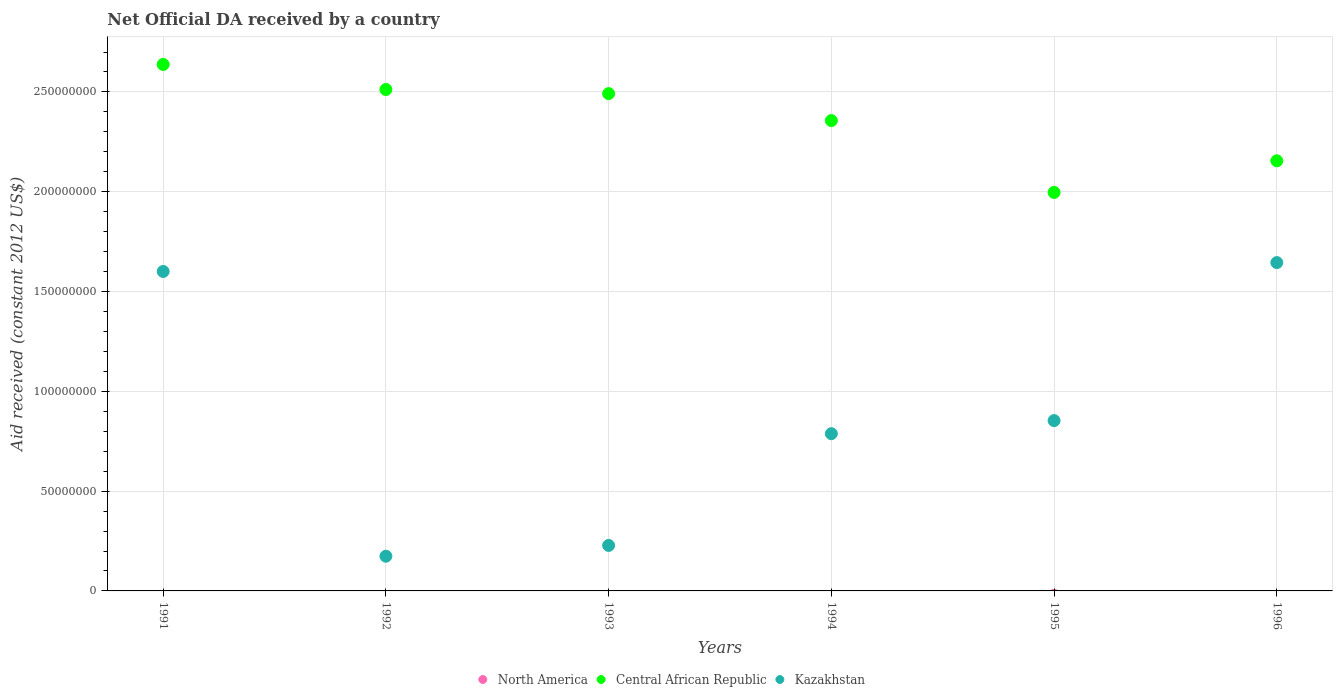What is the net official development assistance aid received in Kazakhstan in 1995?
Your response must be concise. 8.53e+07. Across all years, what is the maximum net official development assistance aid received in Central African Republic?
Ensure brevity in your answer.  2.64e+08. Across all years, what is the minimum net official development assistance aid received in Central African Republic?
Make the answer very short. 2.00e+08. What is the difference between the net official development assistance aid received in Kazakhstan in 1991 and that in 1996?
Give a very brief answer. -4.45e+06. What is the difference between the net official development assistance aid received in North America in 1993 and the net official development assistance aid received in Central African Republic in 1991?
Offer a terse response. -2.64e+08. What is the average net official development assistance aid received in Central African Republic per year?
Your answer should be compact. 2.36e+08. In the year 1993, what is the difference between the net official development assistance aid received in Central African Republic and net official development assistance aid received in Kazakhstan?
Provide a short and direct response. 2.26e+08. In how many years, is the net official development assistance aid received in Central African Republic greater than 40000000 US$?
Your answer should be very brief. 6. What is the ratio of the net official development assistance aid received in Kazakhstan in 1991 to that in 1995?
Your response must be concise. 1.88. Is the net official development assistance aid received in Kazakhstan in 1993 less than that in 1994?
Provide a succinct answer. Yes. What is the difference between the highest and the second highest net official development assistance aid received in Kazakhstan?
Offer a very short reply. 4.45e+06. What is the difference between the highest and the lowest net official development assistance aid received in Kazakhstan?
Provide a short and direct response. 1.47e+08. In how many years, is the net official development assistance aid received in Kazakhstan greater than the average net official development assistance aid received in Kazakhstan taken over all years?
Make the answer very short. 2. Is the sum of the net official development assistance aid received in Kazakhstan in 1991 and 1993 greater than the maximum net official development assistance aid received in North America across all years?
Give a very brief answer. Yes. Does the net official development assistance aid received in North America monotonically increase over the years?
Your response must be concise. No. Is the net official development assistance aid received in Central African Republic strictly less than the net official development assistance aid received in Kazakhstan over the years?
Offer a terse response. No. How many years are there in the graph?
Your answer should be compact. 6. What is the title of the graph?
Offer a terse response. Net Official DA received by a country. Does "Seychelles" appear as one of the legend labels in the graph?
Offer a terse response. No. What is the label or title of the Y-axis?
Ensure brevity in your answer.  Aid received (constant 2012 US$). What is the Aid received (constant 2012 US$) of Central African Republic in 1991?
Offer a terse response. 2.64e+08. What is the Aid received (constant 2012 US$) in Kazakhstan in 1991?
Ensure brevity in your answer.  1.60e+08. What is the Aid received (constant 2012 US$) of Central African Republic in 1992?
Provide a short and direct response. 2.51e+08. What is the Aid received (constant 2012 US$) in Kazakhstan in 1992?
Ensure brevity in your answer.  1.74e+07. What is the Aid received (constant 2012 US$) of Central African Republic in 1993?
Offer a terse response. 2.49e+08. What is the Aid received (constant 2012 US$) in Kazakhstan in 1993?
Your response must be concise. 2.28e+07. What is the Aid received (constant 2012 US$) in North America in 1994?
Provide a succinct answer. 0. What is the Aid received (constant 2012 US$) of Central African Republic in 1994?
Give a very brief answer. 2.36e+08. What is the Aid received (constant 2012 US$) in Kazakhstan in 1994?
Keep it short and to the point. 7.88e+07. What is the Aid received (constant 2012 US$) of Central African Republic in 1995?
Offer a very short reply. 2.00e+08. What is the Aid received (constant 2012 US$) of Kazakhstan in 1995?
Offer a terse response. 8.53e+07. What is the Aid received (constant 2012 US$) of North America in 1996?
Give a very brief answer. 0. What is the Aid received (constant 2012 US$) in Central African Republic in 1996?
Your answer should be compact. 2.15e+08. What is the Aid received (constant 2012 US$) in Kazakhstan in 1996?
Your response must be concise. 1.64e+08. Across all years, what is the maximum Aid received (constant 2012 US$) in Central African Republic?
Make the answer very short. 2.64e+08. Across all years, what is the maximum Aid received (constant 2012 US$) in Kazakhstan?
Provide a short and direct response. 1.64e+08. Across all years, what is the minimum Aid received (constant 2012 US$) in Central African Republic?
Provide a short and direct response. 2.00e+08. Across all years, what is the minimum Aid received (constant 2012 US$) in Kazakhstan?
Offer a terse response. 1.74e+07. What is the total Aid received (constant 2012 US$) of North America in the graph?
Offer a terse response. 0. What is the total Aid received (constant 2012 US$) in Central African Republic in the graph?
Make the answer very short. 1.41e+09. What is the total Aid received (constant 2012 US$) of Kazakhstan in the graph?
Your answer should be compact. 5.29e+08. What is the difference between the Aid received (constant 2012 US$) in Central African Republic in 1991 and that in 1992?
Offer a very short reply. 1.26e+07. What is the difference between the Aid received (constant 2012 US$) in Kazakhstan in 1991 and that in 1992?
Keep it short and to the point. 1.43e+08. What is the difference between the Aid received (constant 2012 US$) in Central African Republic in 1991 and that in 1993?
Your answer should be compact. 1.46e+07. What is the difference between the Aid received (constant 2012 US$) of Kazakhstan in 1991 and that in 1993?
Give a very brief answer. 1.37e+08. What is the difference between the Aid received (constant 2012 US$) of Central African Republic in 1991 and that in 1994?
Your answer should be very brief. 2.81e+07. What is the difference between the Aid received (constant 2012 US$) of Kazakhstan in 1991 and that in 1994?
Ensure brevity in your answer.  8.13e+07. What is the difference between the Aid received (constant 2012 US$) of Central African Republic in 1991 and that in 1995?
Provide a succinct answer. 6.41e+07. What is the difference between the Aid received (constant 2012 US$) of Kazakhstan in 1991 and that in 1995?
Ensure brevity in your answer.  7.47e+07. What is the difference between the Aid received (constant 2012 US$) in Central African Republic in 1991 and that in 1996?
Ensure brevity in your answer.  4.83e+07. What is the difference between the Aid received (constant 2012 US$) in Kazakhstan in 1991 and that in 1996?
Keep it short and to the point. -4.45e+06. What is the difference between the Aid received (constant 2012 US$) of Central African Republic in 1992 and that in 1993?
Ensure brevity in your answer.  2.06e+06. What is the difference between the Aid received (constant 2012 US$) of Kazakhstan in 1992 and that in 1993?
Provide a succinct answer. -5.40e+06. What is the difference between the Aid received (constant 2012 US$) in Central African Republic in 1992 and that in 1994?
Provide a succinct answer. 1.56e+07. What is the difference between the Aid received (constant 2012 US$) in Kazakhstan in 1992 and that in 1994?
Ensure brevity in your answer.  -6.14e+07. What is the difference between the Aid received (constant 2012 US$) of Central African Republic in 1992 and that in 1995?
Make the answer very short. 5.16e+07. What is the difference between the Aid received (constant 2012 US$) of Kazakhstan in 1992 and that in 1995?
Keep it short and to the point. -6.79e+07. What is the difference between the Aid received (constant 2012 US$) of Central African Republic in 1992 and that in 1996?
Make the answer very short. 3.57e+07. What is the difference between the Aid received (constant 2012 US$) of Kazakhstan in 1992 and that in 1996?
Give a very brief answer. -1.47e+08. What is the difference between the Aid received (constant 2012 US$) of Central African Republic in 1993 and that in 1994?
Offer a terse response. 1.35e+07. What is the difference between the Aid received (constant 2012 US$) in Kazakhstan in 1993 and that in 1994?
Provide a succinct answer. -5.60e+07. What is the difference between the Aid received (constant 2012 US$) in Central African Republic in 1993 and that in 1995?
Offer a very short reply. 4.95e+07. What is the difference between the Aid received (constant 2012 US$) of Kazakhstan in 1993 and that in 1995?
Provide a succinct answer. -6.25e+07. What is the difference between the Aid received (constant 2012 US$) of Central African Republic in 1993 and that in 1996?
Ensure brevity in your answer.  3.37e+07. What is the difference between the Aid received (constant 2012 US$) in Kazakhstan in 1993 and that in 1996?
Give a very brief answer. -1.42e+08. What is the difference between the Aid received (constant 2012 US$) of Central African Republic in 1994 and that in 1995?
Your response must be concise. 3.60e+07. What is the difference between the Aid received (constant 2012 US$) of Kazakhstan in 1994 and that in 1995?
Keep it short and to the point. -6.55e+06. What is the difference between the Aid received (constant 2012 US$) of Central African Republic in 1994 and that in 1996?
Ensure brevity in your answer.  2.02e+07. What is the difference between the Aid received (constant 2012 US$) in Kazakhstan in 1994 and that in 1996?
Make the answer very short. -8.57e+07. What is the difference between the Aid received (constant 2012 US$) in Central African Republic in 1995 and that in 1996?
Provide a short and direct response. -1.58e+07. What is the difference between the Aid received (constant 2012 US$) of Kazakhstan in 1995 and that in 1996?
Offer a very short reply. -7.92e+07. What is the difference between the Aid received (constant 2012 US$) in Central African Republic in 1991 and the Aid received (constant 2012 US$) in Kazakhstan in 1992?
Offer a terse response. 2.46e+08. What is the difference between the Aid received (constant 2012 US$) in Central African Republic in 1991 and the Aid received (constant 2012 US$) in Kazakhstan in 1993?
Provide a succinct answer. 2.41e+08. What is the difference between the Aid received (constant 2012 US$) in Central African Republic in 1991 and the Aid received (constant 2012 US$) in Kazakhstan in 1994?
Provide a succinct answer. 1.85e+08. What is the difference between the Aid received (constant 2012 US$) of Central African Republic in 1991 and the Aid received (constant 2012 US$) of Kazakhstan in 1995?
Ensure brevity in your answer.  1.78e+08. What is the difference between the Aid received (constant 2012 US$) in Central African Republic in 1991 and the Aid received (constant 2012 US$) in Kazakhstan in 1996?
Your response must be concise. 9.93e+07. What is the difference between the Aid received (constant 2012 US$) of Central African Republic in 1992 and the Aid received (constant 2012 US$) of Kazakhstan in 1993?
Make the answer very short. 2.28e+08. What is the difference between the Aid received (constant 2012 US$) in Central African Republic in 1992 and the Aid received (constant 2012 US$) in Kazakhstan in 1994?
Offer a very short reply. 1.72e+08. What is the difference between the Aid received (constant 2012 US$) of Central African Republic in 1992 and the Aid received (constant 2012 US$) of Kazakhstan in 1995?
Ensure brevity in your answer.  1.66e+08. What is the difference between the Aid received (constant 2012 US$) in Central African Republic in 1992 and the Aid received (constant 2012 US$) in Kazakhstan in 1996?
Provide a short and direct response. 8.67e+07. What is the difference between the Aid received (constant 2012 US$) of Central African Republic in 1993 and the Aid received (constant 2012 US$) of Kazakhstan in 1994?
Offer a very short reply. 1.70e+08. What is the difference between the Aid received (constant 2012 US$) in Central African Republic in 1993 and the Aid received (constant 2012 US$) in Kazakhstan in 1995?
Make the answer very short. 1.64e+08. What is the difference between the Aid received (constant 2012 US$) of Central African Republic in 1993 and the Aid received (constant 2012 US$) of Kazakhstan in 1996?
Keep it short and to the point. 8.46e+07. What is the difference between the Aid received (constant 2012 US$) of Central African Republic in 1994 and the Aid received (constant 2012 US$) of Kazakhstan in 1995?
Ensure brevity in your answer.  1.50e+08. What is the difference between the Aid received (constant 2012 US$) of Central African Republic in 1994 and the Aid received (constant 2012 US$) of Kazakhstan in 1996?
Provide a succinct answer. 7.12e+07. What is the difference between the Aid received (constant 2012 US$) of Central African Republic in 1995 and the Aid received (constant 2012 US$) of Kazakhstan in 1996?
Give a very brief answer. 3.51e+07. What is the average Aid received (constant 2012 US$) of Central African Republic per year?
Make the answer very short. 2.36e+08. What is the average Aid received (constant 2012 US$) of Kazakhstan per year?
Give a very brief answer. 8.81e+07. In the year 1991, what is the difference between the Aid received (constant 2012 US$) in Central African Republic and Aid received (constant 2012 US$) in Kazakhstan?
Keep it short and to the point. 1.04e+08. In the year 1992, what is the difference between the Aid received (constant 2012 US$) in Central African Republic and Aid received (constant 2012 US$) in Kazakhstan?
Keep it short and to the point. 2.34e+08. In the year 1993, what is the difference between the Aid received (constant 2012 US$) in Central African Republic and Aid received (constant 2012 US$) in Kazakhstan?
Provide a succinct answer. 2.26e+08. In the year 1994, what is the difference between the Aid received (constant 2012 US$) in Central African Republic and Aid received (constant 2012 US$) in Kazakhstan?
Offer a very short reply. 1.57e+08. In the year 1995, what is the difference between the Aid received (constant 2012 US$) of Central African Republic and Aid received (constant 2012 US$) of Kazakhstan?
Your response must be concise. 1.14e+08. In the year 1996, what is the difference between the Aid received (constant 2012 US$) in Central African Republic and Aid received (constant 2012 US$) in Kazakhstan?
Provide a succinct answer. 5.10e+07. What is the ratio of the Aid received (constant 2012 US$) of Kazakhstan in 1991 to that in 1992?
Make the answer very short. 9.2. What is the ratio of the Aid received (constant 2012 US$) of Central African Republic in 1991 to that in 1993?
Provide a succinct answer. 1.06. What is the ratio of the Aid received (constant 2012 US$) in Kazakhstan in 1991 to that in 1993?
Your answer should be very brief. 7.02. What is the ratio of the Aid received (constant 2012 US$) of Central African Republic in 1991 to that in 1994?
Ensure brevity in your answer.  1.12. What is the ratio of the Aid received (constant 2012 US$) in Kazakhstan in 1991 to that in 1994?
Your response must be concise. 2.03. What is the ratio of the Aid received (constant 2012 US$) of Central African Republic in 1991 to that in 1995?
Provide a succinct answer. 1.32. What is the ratio of the Aid received (constant 2012 US$) in Kazakhstan in 1991 to that in 1995?
Offer a terse response. 1.88. What is the ratio of the Aid received (constant 2012 US$) of Central African Republic in 1991 to that in 1996?
Offer a terse response. 1.22. What is the ratio of the Aid received (constant 2012 US$) in Kazakhstan in 1991 to that in 1996?
Ensure brevity in your answer.  0.97. What is the ratio of the Aid received (constant 2012 US$) of Central African Republic in 1992 to that in 1993?
Give a very brief answer. 1.01. What is the ratio of the Aid received (constant 2012 US$) in Kazakhstan in 1992 to that in 1993?
Offer a very short reply. 0.76. What is the ratio of the Aid received (constant 2012 US$) in Central African Republic in 1992 to that in 1994?
Offer a terse response. 1.07. What is the ratio of the Aid received (constant 2012 US$) in Kazakhstan in 1992 to that in 1994?
Keep it short and to the point. 0.22. What is the ratio of the Aid received (constant 2012 US$) of Central African Republic in 1992 to that in 1995?
Your answer should be compact. 1.26. What is the ratio of the Aid received (constant 2012 US$) in Kazakhstan in 1992 to that in 1995?
Ensure brevity in your answer.  0.2. What is the ratio of the Aid received (constant 2012 US$) in Central African Republic in 1992 to that in 1996?
Your response must be concise. 1.17. What is the ratio of the Aid received (constant 2012 US$) in Kazakhstan in 1992 to that in 1996?
Keep it short and to the point. 0.11. What is the ratio of the Aid received (constant 2012 US$) in Central African Republic in 1993 to that in 1994?
Keep it short and to the point. 1.06. What is the ratio of the Aid received (constant 2012 US$) of Kazakhstan in 1993 to that in 1994?
Give a very brief answer. 0.29. What is the ratio of the Aid received (constant 2012 US$) in Central African Republic in 1993 to that in 1995?
Your answer should be very brief. 1.25. What is the ratio of the Aid received (constant 2012 US$) in Kazakhstan in 1993 to that in 1995?
Provide a short and direct response. 0.27. What is the ratio of the Aid received (constant 2012 US$) of Central African Republic in 1993 to that in 1996?
Provide a succinct answer. 1.16. What is the ratio of the Aid received (constant 2012 US$) of Kazakhstan in 1993 to that in 1996?
Your response must be concise. 0.14. What is the ratio of the Aid received (constant 2012 US$) in Central African Republic in 1994 to that in 1995?
Your answer should be very brief. 1.18. What is the ratio of the Aid received (constant 2012 US$) in Kazakhstan in 1994 to that in 1995?
Give a very brief answer. 0.92. What is the ratio of the Aid received (constant 2012 US$) of Central African Republic in 1994 to that in 1996?
Your answer should be compact. 1.09. What is the ratio of the Aid received (constant 2012 US$) of Kazakhstan in 1994 to that in 1996?
Offer a terse response. 0.48. What is the ratio of the Aid received (constant 2012 US$) of Central African Republic in 1995 to that in 1996?
Your response must be concise. 0.93. What is the ratio of the Aid received (constant 2012 US$) of Kazakhstan in 1995 to that in 1996?
Your answer should be compact. 0.52. What is the difference between the highest and the second highest Aid received (constant 2012 US$) in Central African Republic?
Ensure brevity in your answer.  1.26e+07. What is the difference between the highest and the second highest Aid received (constant 2012 US$) in Kazakhstan?
Your answer should be compact. 4.45e+06. What is the difference between the highest and the lowest Aid received (constant 2012 US$) in Central African Republic?
Offer a very short reply. 6.41e+07. What is the difference between the highest and the lowest Aid received (constant 2012 US$) in Kazakhstan?
Keep it short and to the point. 1.47e+08. 